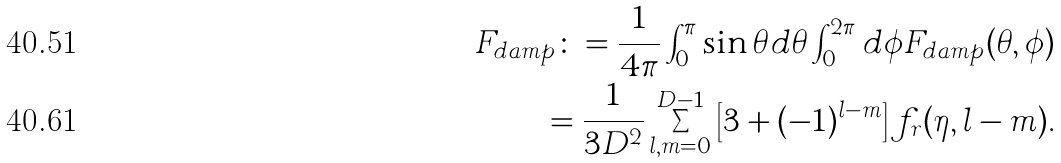<formula> <loc_0><loc_0><loc_500><loc_500>F _ { d a m p } \colon = \frac { 1 } { 4 \pi } \int _ { 0 } ^ { \pi } \sin \theta d \theta \int _ { 0 } ^ { 2 \pi } d \phi F _ { d a m p } ( \theta , \phi ) \\ = \frac { 1 } { 3 D ^ { 2 } } \sum _ { l , m = 0 } ^ { D - 1 } \left [ 3 + ( - 1 ) ^ { l - m } \right ] f _ { r } ( \eta , l - m ) .</formula> 